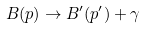Convert formula to latex. <formula><loc_0><loc_0><loc_500><loc_500>B ( p ) \rightarrow B ^ { \prime } ( p ^ { \prime } ) + \gamma</formula> 